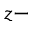Convert formula to latex. <formula><loc_0><loc_0><loc_500><loc_500>z -</formula> 